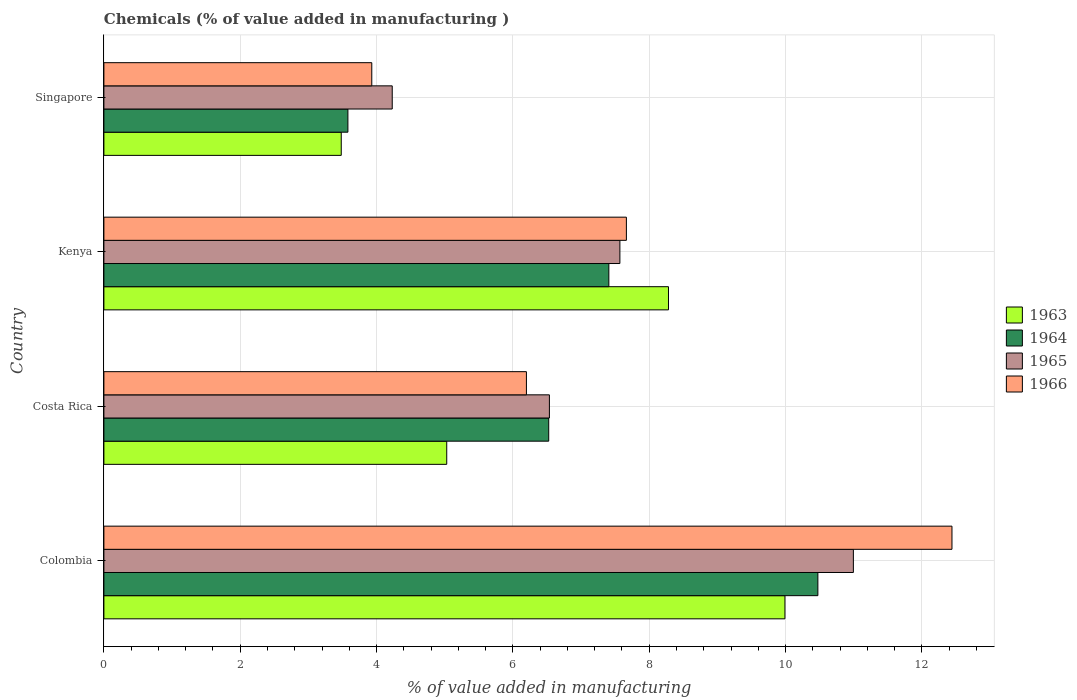How many groups of bars are there?
Provide a short and direct response. 4. Are the number of bars per tick equal to the number of legend labels?
Your answer should be very brief. Yes. How many bars are there on the 2nd tick from the top?
Your answer should be compact. 4. What is the label of the 1st group of bars from the top?
Ensure brevity in your answer.  Singapore. In how many cases, is the number of bars for a given country not equal to the number of legend labels?
Your response must be concise. 0. What is the value added in manufacturing chemicals in 1964 in Colombia?
Your answer should be compact. 10.47. Across all countries, what is the maximum value added in manufacturing chemicals in 1966?
Ensure brevity in your answer.  12.44. Across all countries, what is the minimum value added in manufacturing chemicals in 1966?
Your answer should be very brief. 3.93. In which country was the value added in manufacturing chemicals in 1964 maximum?
Your response must be concise. Colombia. In which country was the value added in manufacturing chemicals in 1965 minimum?
Give a very brief answer. Singapore. What is the total value added in manufacturing chemicals in 1964 in the graph?
Your answer should be very brief. 27.99. What is the difference between the value added in manufacturing chemicals in 1963 in Costa Rica and that in Singapore?
Offer a very short reply. 1.55. What is the difference between the value added in manufacturing chemicals in 1965 in Costa Rica and the value added in manufacturing chemicals in 1964 in Singapore?
Make the answer very short. 2.96. What is the average value added in manufacturing chemicals in 1964 per country?
Your response must be concise. 7. What is the difference between the value added in manufacturing chemicals in 1965 and value added in manufacturing chemicals in 1966 in Singapore?
Offer a very short reply. 0.3. What is the ratio of the value added in manufacturing chemicals in 1964 in Colombia to that in Costa Rica?
Provide a short and direct response. 1.61. What is the difference between the highest and the second highest value added in manufacturing chemicals in 1964?
Ensure brevity in your answer.  3.07. What is the difference between the highest and the lowest value added in manufacturing chemicals in 1965?
Provide a short and direct response. 6.76. Is the sum of the value added in manufacturing chemicals in 1964 in Costa Rica and Singapore greater than the maximum value added in manufacturing chemicals in 1966 across all countries?
Offer a terse response. No. What does the 2nd bar from the bottom in Singapore represents?
Provide a succinct answer. 1964. How many countries are there in the graph?
Offer a very short reply. 4. Are the values on the major ticks of X-axis written in scientific E-notation?
Offer a very short reply. No. Does the graph contain grids?
Provide a short and direct response. Yes. Where does the legend appear in the graph?
Ensure brevity in your answer.  Center right. How many legend labels are there?
Make the answer very short. 4. What is the title of the graph?
Keep it short and to the point. Chemicals (% of value added in manufacturing ). Does "1988" appear as one of the legend labels in the graph?
Make the answer very short. No. What is the label or title of the X-axis?
Ensure brevity in your answer.  % of value added in manufacturing. What is the % of value added in manufacturing in 1963 in Colombia?
Your answer should be very brief. 9.99. What is the % of value added in manufacturing in 1964 in Colombia?
Keep it short and to the point. 10.47. What is the % of value added in manufacturing of 1965 in Colombia?
Your response must be concise. 10.99. What is the % of value added in manufacturing in 1966 in Colombia?
Ensure brevity in your answer.  12.44. What is the % of value added in manufacturing in 1963 in Costa Rica?
Ensure brevity in your answer.  5.03. What is the % of value added in manufacturing of 1964 in Costa Rica?
Ensure brevity in your answer.  6.53. What is the % of value added in manufacturing in 1965 in Costa Rica?
Offer a terse response. 6.54. What is the % of value added in manufacturing of 1966 in Costa Rica?
Give a very brief answer. 6.2. What is the % of value added in manufacturing of 1963 in Kenya?
Keep it short and to the point. 8.28. What is the % of value added in manufacturing in 1964 in Kenya?
Offer a very short reply. 7.41. What is the % of value added in manufacturing in 1965 in Kenya?
Offer a terse response. 7.57. What is the % of value added in manufacturing of 1966 in Kenya?
Your response must be concise. 7.67. What is the % of value added in manufacturing of 1963 in Singapore?
Make the answer very short. 3.48. What is the % of value added in manufacturing of 1964 in Singapore?
Ensure brevity in your answer.  3.58. What is the % of value added in manufacturing in 1965 in Singapore?
Ensure brevity in your answer.  4.23. What is the % of value added in manufacturing in 1966 in Singapore?
Offer a very short reply. 3.93. Across all countries, what is the maximum % of value added in manufacturing in 1963?
Offer a very short reply. 9.99. Across all countries, what is the maximum % of value added in manufacturing in 1964?
Your response must be concise. 10.47. Across all countries, what is the maximum % of value added in manufacturing in 1965?
Ensure brevity in your answer.  10.99. Across all countries, what is the maximum % of value added in manufacturing in 1966?
Your response must be concise. 12.44. Across all countries, what is the minimum % of value added in manufacturing in 1963?
Make the answer very short. 3.48. Across all countries, what is the minimum % of value added in manufacturing of 1964?
Provide a succinct answer. 3.58. Across all countries, what is the minimum % of value added in manufacturing of 1965?
Your answer should be very brief. 4.23. Across all countries, what is the minimum % of value added in manufacturing of 1966?
Your response must be concise. 3.93. What is the total % of value added in manufacturing in 1963 in the graph?
Your answer should be compact. 26.79. What is the total % of value added in manufacturing in 1964 in the graph?
Offer a very short reply. 27.99. What is the total % of value added in manufacturing of 1965 in the graph?
Keep it short and to the point. 29.33. What is the total % of value added in manufacturing in 1966 in the graph?
Offer a terse response. 30.23. What is the difference between the % of value added in manufacturing of 1963 in Colombia and that in Costa Rica?
Provide a short and direct response. 4.96. What is the difference between the % of value added in manufacturing of 1964 in Colombia and that in Costa Rica?
Offer a very short reply. 3.95. What is the difference between the % of value added in manufacturing of 1965 in Colombia and that in Costa Rica?
Your answer should be very brief. 4.46. What is the difference between the % of value added in manufacturing in 1966 in Colombia and that in Costa Rica?
Provide a short and direct response. 6.24. What is the difference between the % of value added in manufacturing in 1963 in Colombia and that in Kenya?
Provide a short and direct response. 1.71. What is the difference between the % of value added in manufacturing of 1964 in Colombia and that in Kenya?
Your response must be concise. 3.07. What is the difference between the % of value added in manufacturing of 1965 in Colombia and that in Kenya?
Provide a succinct answer. 3.43. What is the difference between the % of value added in manufacturing in 1966 in Colombia and that in Kenya?
Keep it short and to the point. 4.78. What is the difference between the % of value added in manufacturing of 1963 in Colombia and that in Singapore?
Your answer should be very brief. 6.51. What is the difference between the % of value added in manufacturing in 1964 in Colombia and that in Singapore?
Provide a short and direct response. 6.89. What is the difference between the % of value added in manufacturing in 1965 in Colombia and that in Singapore?
Make the answer very short. 6.76. What is the difference between the % of value added in manufacturing of 1966 in Colombia and that in Singapore?
Your answer should be compact. 8.51. What is the difference between the % of value added in manufacturing of 1963 in Costa Rica and that in Kenya?
Your answer should be very brief. -3.25. What is the difference between the % of value added in manufacturing of 1964 in Costa Rica and that in Kenya?
Provide a succinct answer. -0.88. What is the difference between the % of value added in manufacturing in 1965 in Costa Rica and that in Kenya?
Offer a very short reply. -1.03. What is the difference between the % of value added in manufacturing in 1966 in Costa Rica and that in Kenya?
Your response must be concise. -1.47. What is the difference between the % of value added in manufacturing in 1963 in Costa Rica and that in Singapore?
Offer a very short reply. 1.55. What is the difference between the % of value added in manufacturing in 1964 in Costa Rica and that in Singapore?
Offer a very short reply. 2.95. What is the difference between the % of value added in manufacturing of 1965 in Costa Rica and that in Singapore?
Provide a short and direct response. 2.31. What is the difference between the % of value added in manufacturing in 1966 in Costa Rica and that in Singapore?
Your response must be concise. 2.27. What is the difference between the % of value added in manufacturing of 1963 in Kenya and that in Singapore?
Ensure brevity in your answer.  4.8. What is the difference between the % of value added in manufacturing of 1964 in Kenya and that in Singapore?
Make the answer very short. 3.83. What is the difference between the % of value added in manufacturing in 1965 in Kenya and that in Singapore?
Offer a very short reply. 3.34. What is the difference between the % of value added in manufacturing in 1966 in Kenya and that in Singapore?
Your answer should be very brief. 3.74. What is the difference between the % of value added in manufacturing in 1963 in Colombia and the % of value added in manufacturing in 1964 in Costa Rica?
Your answer should be very brief. 3.47. What is the difference between the % of value added in manufacturing in 1963 in Colombia and the % of value added in manufacturing in 1965 in Costa Rica?
Provide a succinct answer. 3.46. What is the difference between the % of value added in manufacturing in 1963 in Colombia and the % of value added in manufacturing in 1966 in Costa Rica?
Give a very brief answer. 3.79. What is the difference between the % of value added in manufacturing in 1964 in Colombia and the % of value added in manufacturing in 1965 in Costa Rica?
Give a very brief answer. 3.94. What is the difference between the % of value added in manufacturing in 1964 in Colombia and the % of value added in manufacturing in 1966 in Costa Rica?
Ensure brevity in your answer.  4.28. What is the difference between the % of value added in manufacturing in 1965 in Colombia and the % of value added in manufacturing in 1966 in Costa Rica?
Provide a short and direct response. 4.8. What is the difference between the % of value added in manufacturing of 1963 in Colombia and the % of value added in manufacturing of 1964 in Kenya?
Keep it short and to the point. 2.58. What is the difference between the % of value added in manufacturing in 1963 in Colombia and the % of value added in manufacturing in 1965 in Kenya?
Provide a succinct answer. 2.42. What is the difference between the % of value added in manufacturing in 1963 in Colombia and the % of value added in manufacturing in 1966 in Kenya?
Offer a very short reply. 2.33. What is the difference between the % of value added in manufacturing of 1964 in Colombia and the % of value added in manufacturing of 1965 in Kenya?
Ensure brevity in your answer.  2.9. What is the difference between the % of value added in manufacturing of 1964 in Colombia and the % of value added in manufacturing of 1966 in Kenya?
Offer a very short reply. 2.81. What is the difference between the % of value added in manufacturing of 1965 in Colombia and the % of value added in manufacturing of 1966 in Kenya?
Make the answer very short. 3.33. What is the difference between the % of value added in manufacturing of 1963 in Colombia and the % of value added in manufacturing of 1964 in Singapore?
Provide a succinct answer. 6.41. What is the difference between the % of value added in manufacturing in 1963 in Colombia and the % of value added in manufacturing in 1965 in Singapore?
Provide a succinct answer. 5.76. What is the difference between the % of value added in manufacturing of 1963 in Colombia and the % of value added in manufacturing of 1966 in Singapore?
Ensure brevity in your answer.  6.06. What is the difference between the % of value added in manufacturing of 1964 in Colombia and the % of value added in manufacturing of 1965 in Singapore?
Ensure brevity in your answer.  6.24. What is the difference between the % of value added in manufacturing of 1964 in Colombia and the % of value added in manufacturing of 1966 in Singapore?
Offer a terse response. 6.54. What is the difference between the % of value added in manufacturing of 1965 in Colombia and the % of value added in manufacturing of 1966 in Singapore?
Ensure brevity in your answer.  7.07. What is the difference between the % of value added in manufacturing of 1963 in Costa Rica and the % of value added in manufacturing of 1964 in Kenya?
Provide a succinct answer. -2.38. What is the difference between the % of value added in manufacturing of 1963 in Costa Rica and the % of value added in manufacturing of 1965 in Kenya?
Your answer should be compact. -2.54. What is the difference between the % of value added in manufacturing in 1963 in Costa Rica and the % of value added in manufacturing in 1966 in Kenya?
Give a very brief answer. -2.64. What is the difference between the % of value added in manufacturing in 1964 in Costa Rica and the % of value added in manufacturing in 1965 in Kenya?
Offer a very short reply. -1.04. What is the difference between the % of value added in manufacturing of 1964 in Costa Rica and the % of value added in manufacturing of 1966 in Kenya?
Ensure brevity in your answer.  -1.14. What is the difference between the % of value added in manufacturing of 1965 in Costa Rica and the % of value added in manufacturing of 1966 in Kenya?
Make the answer very short. -1.13. What is the difference between the % of value added in manufacturing of 1963 in Costa Rica and the % of value added in manufacturing of 1964 in Singapore?
Give a very brief answer. 1.45. What is the difference between the % of value added in manufacturing in 1963 in Costa Rica and the % of value added in manufacturing in 1965 in Singapore?
Your response must be concise. 0.8. What is the difference between the % of value added in manufacturing of 1963 in Costa Rica and the % of value added in manufacturing of 1966 in Singapore?
Your answer should be compact. 1.1. What is the difference between the % of value added in manufacturing in 1964 in Costa Rica and the % of value added in manufacturing in 1965 in Singapore?
Give a very brief answer. 2.3. What is the difference between the % of value added in manufacturing in 1964 in Costa Rica and the % of value added in manufacturing in 1966 in Singapore?
Offer a very short reply. 2.6. What is the difference between the % of value added in manufacturing in 1965 in Costa Rica and the % of value added in manufacturing in 1966 in Singapore?
Provide a short and direct response. 2.61. What is the difference between the % of value added in manufacturing of 1963 in Kenya and the % of value added in manufacturing of 1964 in Singapore?
Offer a terse response. 4.7. What is the difference between the % of value added in manufacturing in 1963 in Kenya and the % of value added in manufacturing in 1965 in Singapore?
Provide a succinct answer. 4.05. What is the difference between the % of value added in manufacturing in 1963 in Kenya and the % of value added in manufacturing in 1966 in Singapore?
Provide a short and direct response. 4.35. What is the difference between the % of value added in manufacturing in 1964 in Kenya and the % of value added in manufacturing in 1965 in Singapore?
Ensure brevity in your answer.  3.18. What is the difference between the % of value added in manufacturing of 1964 in Kenya and the % of value added in manufacturing of 1966 in Singapore?
Offer a very short reply. 3.48. What is the difference between the % of value added in manufacturing in 1965 in Kenya and the % of value added in manufacturing in 1966 in Singapore?
Provide a succinct answer. 3.64. What is the average % of value added in manufacturing of 1963 per country?
Keep it short and to the point. 6.7. What is the average % of value added in manufacturing of 1964 per country?
Offer a terse response. 7. What is the average % of value added in manufacturing of 1965 per country?
Provide a succinct answer. 7.33. What is the average % of value added in manufacturing in 1966 per country?
Offer a terse response. 7.56. What is the difference between the % of value added in manufacturing in 1963 and % of value added in manufacturing in 1964 in Colombia?
Your response must be concise. -0.48. What is the difference between the % of value added in manufacturing in 1963 and % of value added in manufacturing in 1965 in Colombia?
Keep it short and to the point. -1. What is the difference between the % of value added in manufacturing of 1963 and % of value added in manufacturing of 1966 in Colombia?
Your answer should be very brief. -2.45. What is the difference between the % of value added in manufacturing of 1964 and % of value added in manufacturing of 1965 in Colombia?
Keep it short and to the point. -0.52. What is the difference between the % of value added in manufacturing in 1964 and % of value added in manufacturing in 1966 in Colombia?
Your answer should be very brief. -1.97. What is the difference between the % of value added in manufacturing in 1965 and % of value added in manufacturing in 1966 in Colombia?
Offer a very short reply. -1.45. What is the difference between the % of value added in manufacturing in 1963 and % of value added in manufacturing in 1964 in Costa Rica?
Ensure brevity in your answer.  -1.5. What is the difference between the % of value added in manufacturing of 1963 and % of value added in manufacturing of 1965 in Costa Rica?
Provide a short and direct response. -1.51. What is the difference between the % of value added in manufacturing in 1963 and % of value added in manufacturing in 1966 in Costa Rica?
Provide a short and direct response. -1.17. What is the difference between the % of value added in manufacturing in 1964 and % of value added in manufacturing in 1965 in Costa Rica?
Your answer should be very brief. -0.01. What is the difference between the % of value added in manufacturing in 1964 and % of value added in manufacturing in 1966 in Costa Rica?
Ensure brevity in your answer.  0.33. What is the difference between the % of value added in manufacturing in 1965 and % of value added in manufacturing in 1966 in Costa Rica?
Give a very brief answer. 0.34. What is the difference between the % of value added in manufacturing of 1963 and % of value added in manufacturing of 1964 in Kenya?
Make the answer very short. 0.87. What is the difference between the % of value added in manufacturing of 1963 and % of value added in manufacturing of 1965 in Kenya?
Keep it short and to the point. 0.71. What is the difference between the % of value added in manufacturing of 1963 and % of value added in manufacturing of 1966 in Kenya?
Keep it short and to the point. 0.62. What is the difference between the % of value added in manufacturing in 1964 and % of value added in manufacturing in 1965 in Kenya?
Your answer should be compact. -0.16. What is the difference between the % of value added in manufacturing of 1964 and % of value added in manufacturing of 1966 in Kenya?
Provide a short and direct response. -0.26. What is the difference between the % of value added in manufacturing of 1965 and % of value added in manufacturing of 1966 in Kenya?
Your response must be concise. -0.1. What is the difference between the % of value added in manufacturing of 1963 and % of value added in manufacturing of 1964 in Singapore?
Your answer should be very brief. -0.1. What is the difference between the % of value added in manufacturing in 1963 and % of value added in manufacturing in 1965 in Singapore?
Offer a very short reply. -0.75. What is the difference between the % of value added in manufacturing of 1963 and % of value added in manufacturing of 1966 in Singapore?
Make the answer very short. -0.45. What is the difference between the % of value added in manufacturing in 1964 and % of value added in manufacturing in 1965 in Singapore?
Provide a short and direct response. -0.65. What is the difference between the % of value added in manufacturing of 1964 and % of value added in manufacturing of 1966 in Singapore?
Offer a very short reply. -0.35. What is the difference between the % of value added in manufacturing in 1965 and % of value added in manufacturing in 1966 in Singapore?
Give a very brief answer. 0.3. What is the ratio of the % of value added in manufacturing of 1963 in Colombia to that in Costa Rica?
Give a very brief answer. 1.99. What is the ratio of the % of value added in manufacturing of 1964 in Colombia to that in Costa Rica?
Ensure brevity in your answer.  1.61. What is the ratio of the % of value added in manufacturing in 1965 in Colombia to that in Costa Rica?
Offer a very short reply. 1.68. What is the ratio of the % of value added in manufacturing of 1966 in Colombia to that in Costa Rica?
Your response must be concise. 2.01. What is the ratio of the % of value added in manufacturing in 1963 in Colombia to that in Kenya?
Your response must be concise. 1.21. What is the ratio of the % of value added in manufacturing in 1964 in Colombia to that in Kenya?
Make the answer very short. 1.41. What is the ratio of the % of value added in manufacturing of 1965 in Colombia to that in Kenya?
Keep it short and to the point. 1.45. What is the ratio of the % of value added in manufacturing in 1966 in Colombia to that in Kenya?
Offer a very short reply. 1.62. What is the ratio of the % of value added in manufacturing of 1963 in Colombia to that in Singapore?
Your response must be concise. 2.87. What is the ratio of the % of value added in manufacturing in 1964 in Colombia to that in Singapore?
Give a very brief answer. 2.93. What is the ratio of the % of value added in manufacturing of 1965 in Colombia to that in Singapore?
Give a very brief answer. 2.6. What is the ratio of the % of value added in manufacturing in 1966 in Colombia to that in Singapore?
Your answer should be compact. 3.17. What is the ratio of the % of value added in manufacturing in 1963 in Costa Rica to that in Kenya?
Your response must be concise. 0.61. What is the ratio of the % of value added in manufacturing in 1964 in Costa Rica to that in Kenya?
Ensure brevity in your answer.  0.88. What is the ratio of the % of value added in manufacturing in 1965 in Costa Rica to that in Kenya?
Offer a very short reply. 0.86. What is the ratio of the % of value added in manufacturing in 1966 in Costa Rica to that in Kenya?
Give a very brief answer. 0.81. What is the ratio of the % of value added in manufacturing in 1963 in Costa Rica to that in Singapore?
Offer a terse response. 1.44. What is the ratio of the % of value added in manufacturing of 1964 in Costa Rica to that in Singapore?
Your response must be concise. 1.82. What is the ratio of the % of value added in manufacturing of 1965 in Costa Rica to that in Singapore?
Offer a very short reply. 1.55. What is the ratio of the % of value added in manufacturing of 1966 in Costa Rica to that in Singapore?
Your answer should be compact. 1.58. What is the ratio of the % of value added in manufacturing in 1963 in Kenya to that in Singapore?
Your response must be concise. 2.38. What is the ratio of the % of value added in manufacturing in 1964 in Kenya to that in Singapore?
Your answer should be compact. 2.07. What is the ratio of the % of value added in manufacturing of 1965 in Kenya to that in Singapore?
Ensure brevity in your answer.  1.79. What is the ratio of the % of value added in manufacturing of 1966 in Kenya to that in Singapore?
Provide a short and direct response. 1.95. What is the difference between the highest and the second highest % of value added in manufacturing of 1963?
Your answer should be very brief. 1.71. What is the difference between the highest and the second highest % of value added in manufacturing in 1964?
Your answer should be very brief. 3.07. What is the difference between the highest and the second highest % of value added in manufacturing in 1965?
Offer a terse response. 3.43. What is the difference between the highest and the second highest % of value added in manufacturing in 1966?
Your response must be concise. 4.78. What is the difference between the highest and the lowest % of value added in manufacturing of 1963?
Make the answer very short. 6.51. What is the difference between the highest and the lowest % of value added in manufacturing of 1964?
Offer a terse response. 6.89. What is the difference between the highest and the lowest % of value added in manufacturing of 1965?
Ensure brevity in your answer.  6.76. What is the difference between the highest and the lowest % of value added in manufacturing of 1966?
Offer a very short reply. 8.51. 